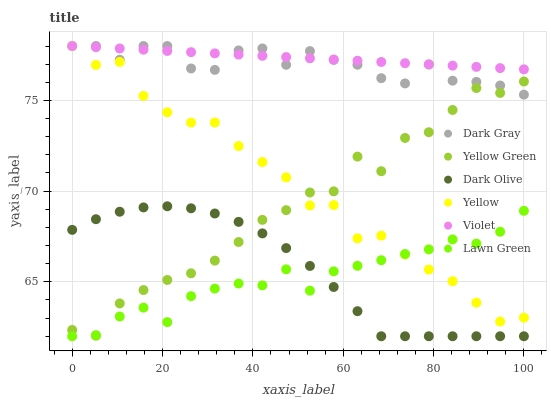Does Lawn Green have the minimum area under the curve?
Answer yes or no. Yes. Does Violet have the maximum area under the curve?
Answer yes or no. Yes. Does Yellow Green have the minimum area under the curve?
Answer yes or no. No. Does Yellow Green have the maximum area under the curve?
Answer yes or no. No. Is Violet the smoothest?
Answer yes or no. Yes. Is Yellow Green the roughest?
Answer yes or no. Yes. Is Dark Olive the smoothest?
Answer yes or no. No. Is Dark Olive the roughest?
Answer yes or no. No. Does Lawn Green have the lowest value?
Answer yes or no. Yes. Does Yellow Green have the lowest value?
Answer yes or no. No. Does Violet have the highest value?
Answer yes or no. Yes. Does Yellow Green have the highest value?
Answer yes or no. No. Is Lawn Green less than Dark Gray?
Answer yes or no. Yes. Is Violet greater than Yellow Green?
Answer yes or no. Yes. Does Yellow Green intersect Yellow?
Answer yes or no. Yes. Is Yellow Green less than Yellow?
Answer yes or no. No. Is Yellow Green greater than Yellow?
Answer yes or no. No. Does Lawn Green intersect Dark Gray?
Answer yes or no. No. 